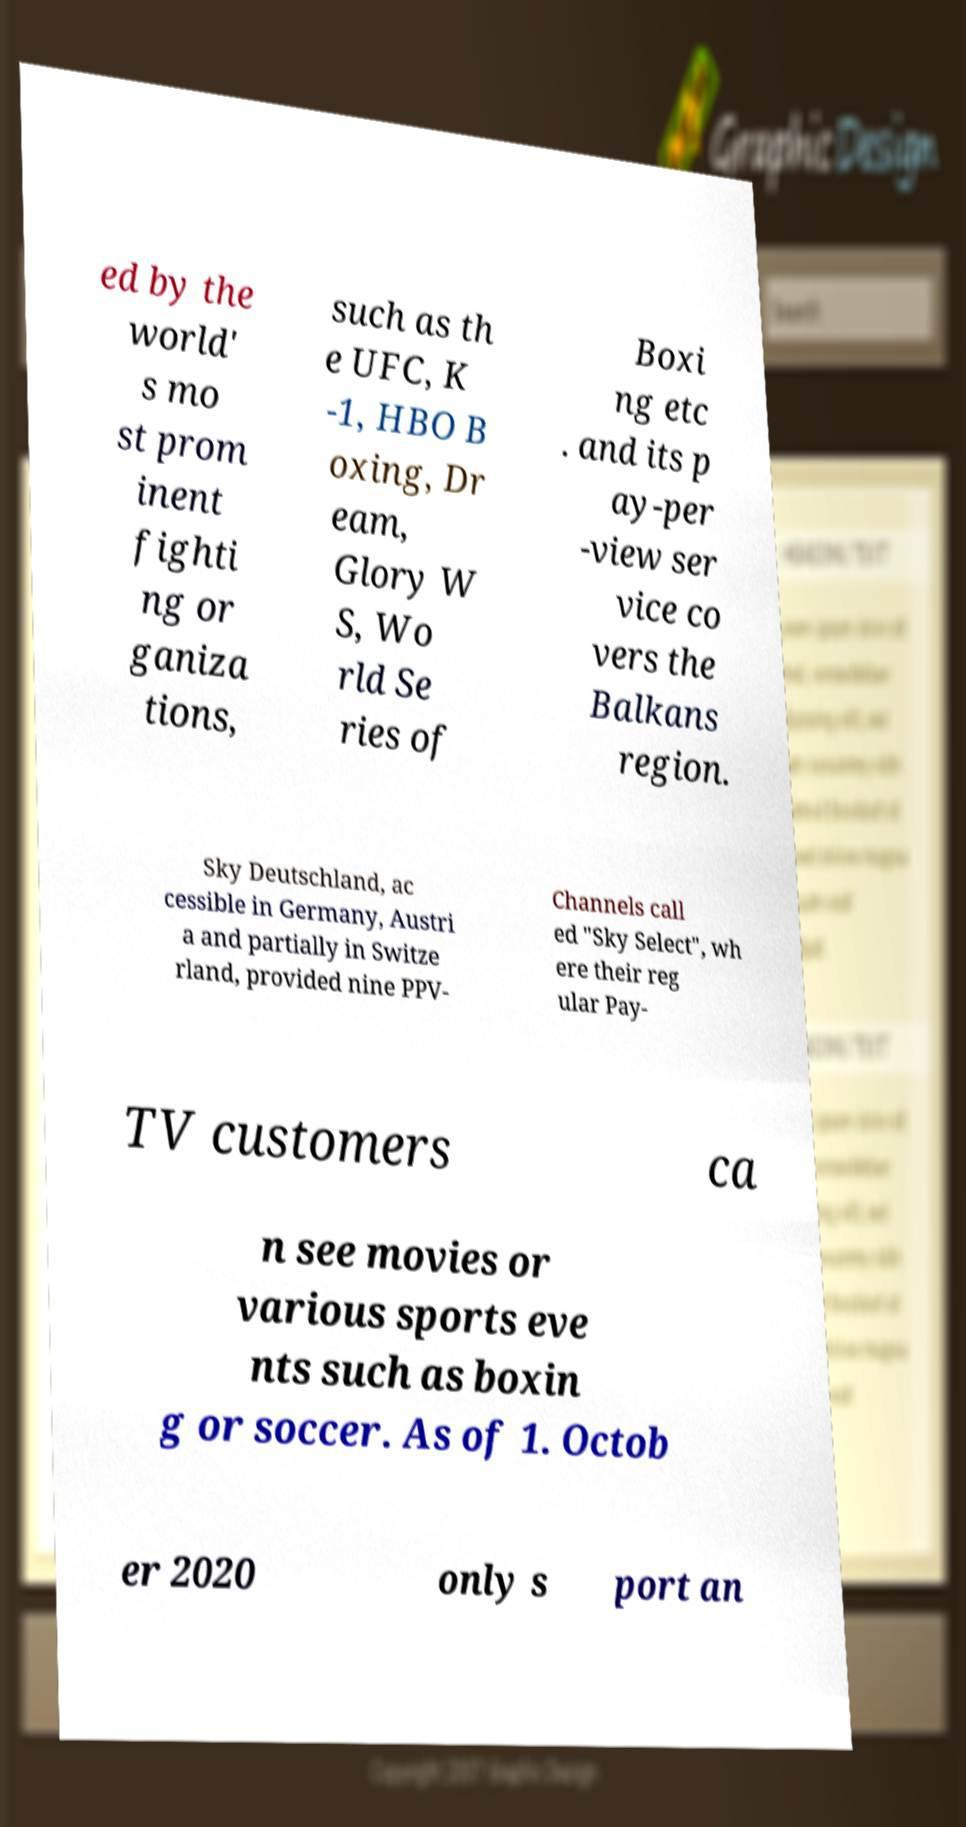Can you accurately transcribe the text from the provided image for me? ed by the world' s mo st prom inent fighti ng or ganiza tions, such as th e UFC, K -1, HBO B oxing, Dr eam, Glory W S, Wo rld Se ries of Boxi ng etc . and its p ay-per -view ser vice co vers the Balkans region. Sky Deutschland, ac cessible in Germany, Austri a and partially in Switze rland, provided nine PPV- Channels call ed "Sky Select", wh ere their reg ular Pay- TV customers ca n see movies or various sports eve nts such as boxin g or soccer. As of 1. Octob er 2020 only s port an 